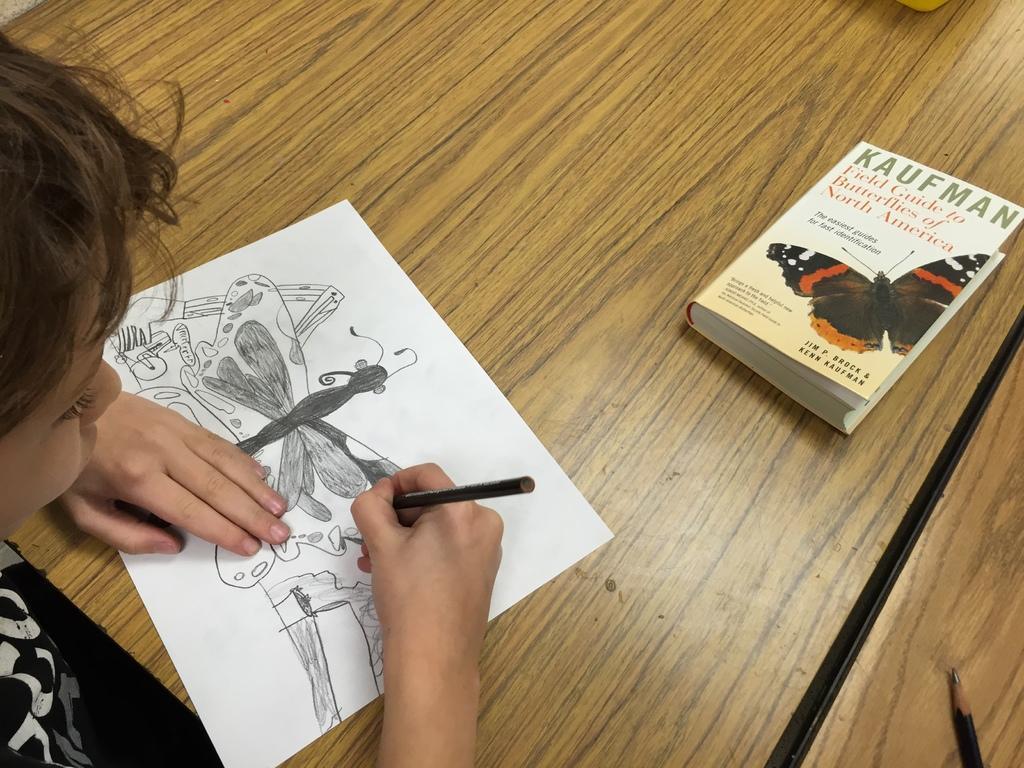Please provide a concise description of this image. In this image there is a kid drawing a sketch on a paper by using a pencil on the table. On the table there is a book and a pencil. 